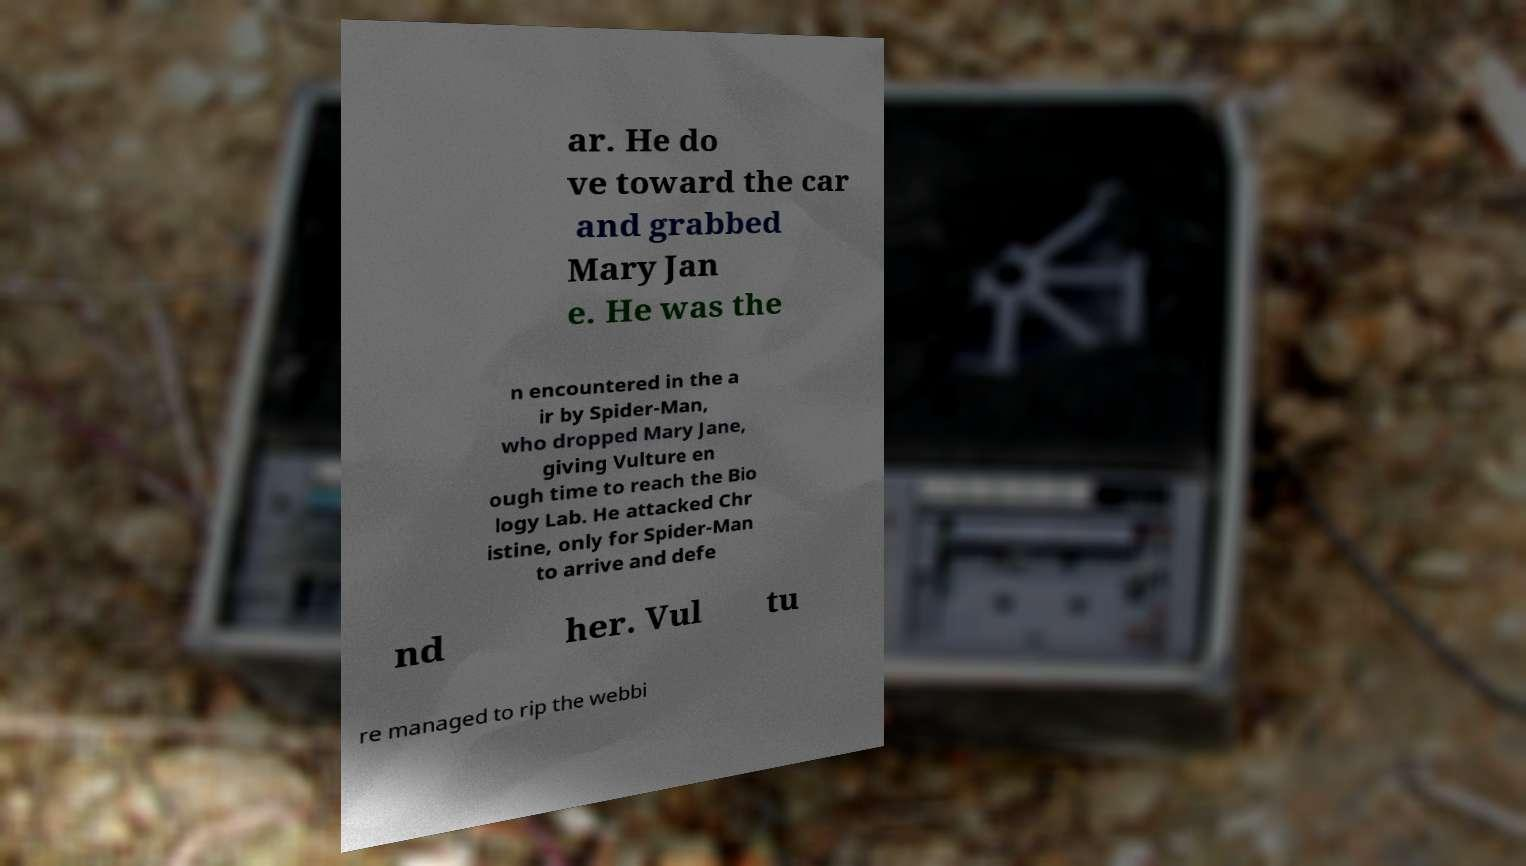Please identify and transcribe the text found in this image. ar. He do ve toward the car and grabbed Mary Jan e. He was the n encountered in the a ir by Spider-Man, who dropped Mary Jane, giving Vulture en ough time to reach the Bio logy Lab. He attacked Chr istine, only for Spider-Man to arrive and defe nd her. Vul tu re managed to rip the webbi 